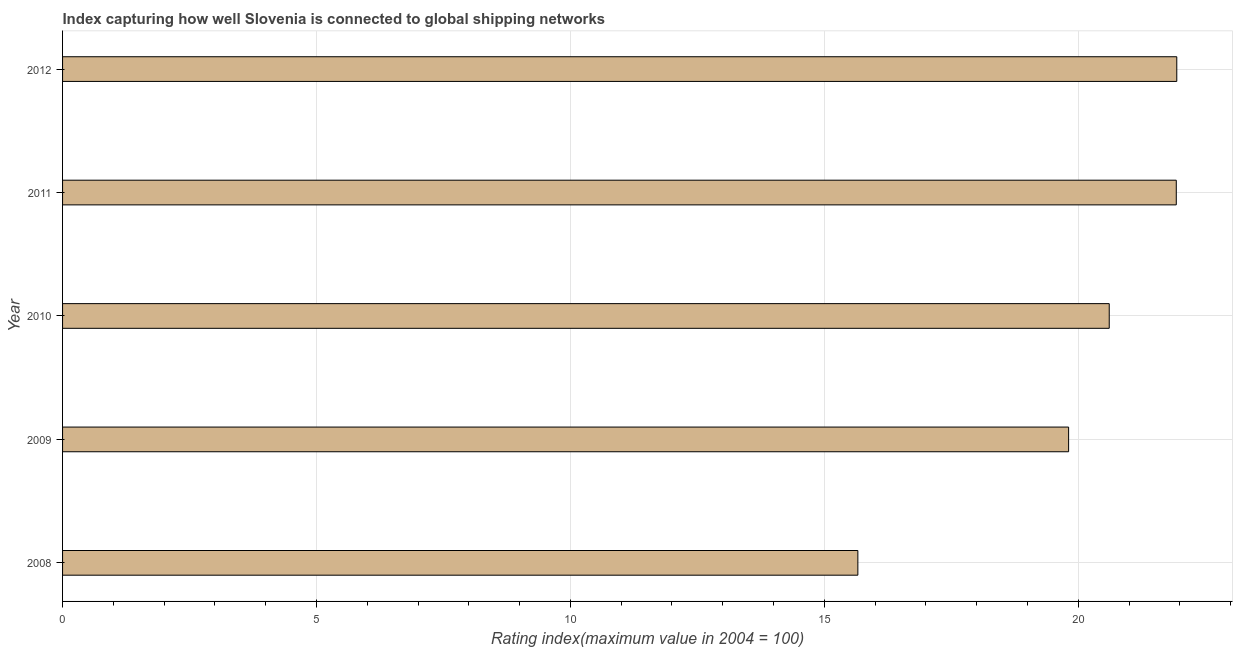What is the title of the graph?
Ensure brevity in your answer.  Index capturing how well Slovenia is connected to global shipping networks. What is the label or title of the X-axis?
Provide a short and direct response. Rating index(maximum value in 2004 = 100). What is the label or title of the Y-axis?
Ensure brevity in your answer.  Year. What is the liner shipping connectivity index in 2008?
Keep it short and to the point. 15.66. Across all years, what is the maximum liner shipping connectivity index?
Your answer should be very brief. 21.94. Across all years, what is the minimum liner shipping connectivity index?
Keep it short and to the point. 15.66. In which year was the liner shipping connectivity index maximum?
Provide a short and direct response. 2012. In which year was the liner shipping connectivity index minimum?
Keep it short and to the point. 2008. What is the sum of the liner shipping connectivity index?
Offer a very short reply. 99.95. What is the difference between the liner shipping connectivity index in 2008 and 2011?
Your answer should be very brief. -6.27. What is the average liner shipping connectivity index per year?
Your answer should be compact. 19.99. What is the median liner shipping connectivity index?
Your answer should be very brief. 20.61. What is the ratio of the liner shipping connectivity index in 2009 to that in 2011?
Provide a short and direct response. 0.9. Is the liner shipping connectivity index in 2008 less than that in 2011?
Your response must be concise. Yes. What is the difference between the highest and the second highest liner shipping connectivity index?
Keep it short and to the point. 0.01. What is the difference between the highest and the lowest liner shipping connectivity index?
Keep it short and to the point. 6.28. In how many years, is the liner shipping connectivity index greater than the average liner shipping connectivity index taken over all years?
Provide a succinct answer. 3. Are all the bars in the graph horizontal?
Give a very brief answer. Yes. How many years are there in the graph?
Offer a very short reply. 5. What is the difference between two consecutive major ticks on the X-axis?
Provide a short and direct response. 5. Are the values on the major ticks of X-axis written in scientific E-notation?
Give a very brief answer. No. What is the Rating index(maximum value in 2004 = 100) of 2008?
Provide a short and direct response. 15.66. What is the Rating index(maximum value in 2004 = 100) in 2009?
Make the answer very short. 19.81. What is the Rating index(maximum value in 2004 = 100) of 2010?
Provide a succinct answer. 20.61. What is the Rating index(maximum value in 2004 = 100) in 2011?
Offer a very short reply. 21.93. What is the Rating index(maximum value in 2004 = 100) in 2012?
Give a very brief answer. 21.94. What is the difference between the Rating index(maximum value in 2004 = 100) in 2008 and 2009?
Your answer should be very brief. -4.15. What is the difference between the Rating index(maximum value in 2004 = 100) in 2008 and 2010?
Provide a succinct answer. -4.95. What is the difference between the Rating index(maximum value in 2004 = 100) in 2008 and 2011?
Give a very brief answer. -6.27. What is the difference between the Rating index(maximum value in 2004 = 100) in 2008 and 2012?
Your answer should be compact. -6.28. What is the difference between the Rating index(maximum value in 2004 = 100) in 2009 and 2010?
Make the answer very short. -0.8. What is the difference between the Rating index(maximum value in 2004 = 100) in 2009 and 2011?
Your response must be concise. -2.12. What is the difference between the Rating index(maximum value in 2004 = 100) in 2009 and 2012?
Give a very brief answer. -2.13. What is the difference between the Rating index(maximum value in 2004 = 100) in 2010 and 2011?
Keep it short and to the point. -1.32. What is the difference between the Rating index(maximum value in 2004 = 100) in 2010 and 2012?
Offer a terse response. -1.33. What is the difference between the Rating index(maximum value in 2004 = 100) in 2011 and 2012?
Provide a succinct answer. -0.01. What is the ratio of the Rating index(maximum value in 2004 = 100) in 2008 to that in 2009?
Your response must be concise. 0.79. What is the ratio of the Rating index(maximum value in 2004 = 100) in 2008 to that in 2010?
Give a very brief answer. 0.76. What is the ratio of the Rating index(maximum value in 2004 = 100) in 2008 to that in 2011?
Ensure brevity in your answer.  0.71. What is the ratio of the Rating index(maximum value in 2004 = 100) in 2008 to that in 2012?
Your response must be concise. 0.71. What is the ratio of the Rating index(maximum value in 2004 = 100) in 2009 to that in 2010?
Ensure brevity in your answer.  0.96. What is the ratio of the Rating index(maximum value in 2004 = 100) in 2009 to that in 2011?
Provide a short and direct response. 0.9. What is the ratio of the Rating index(maximum value in 2004 = 100) in 2009 to that in 2012?
Provide a succinct answer. 0.9. What is the ratio of the Rating index(maximum value in 2004 = 100) in 2010 to that in 2012?
Ensure brevity in your answer.  0.94. 